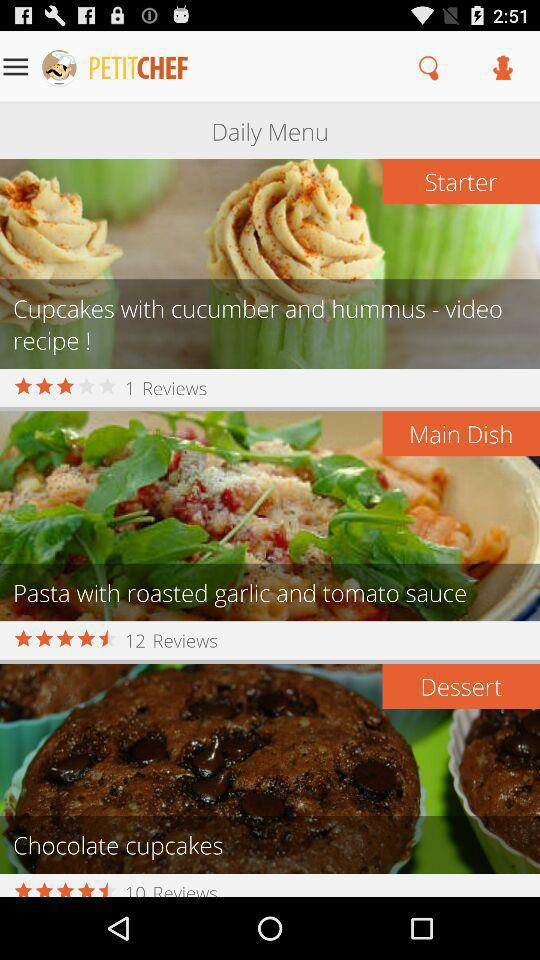How many reviews are there for the starter dish? There is 1 review. 